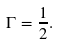<formula> <loc_0><loc_0><loc_500><loc_500>\Gamma = \frac { 1 } { 2 } .</formula> 